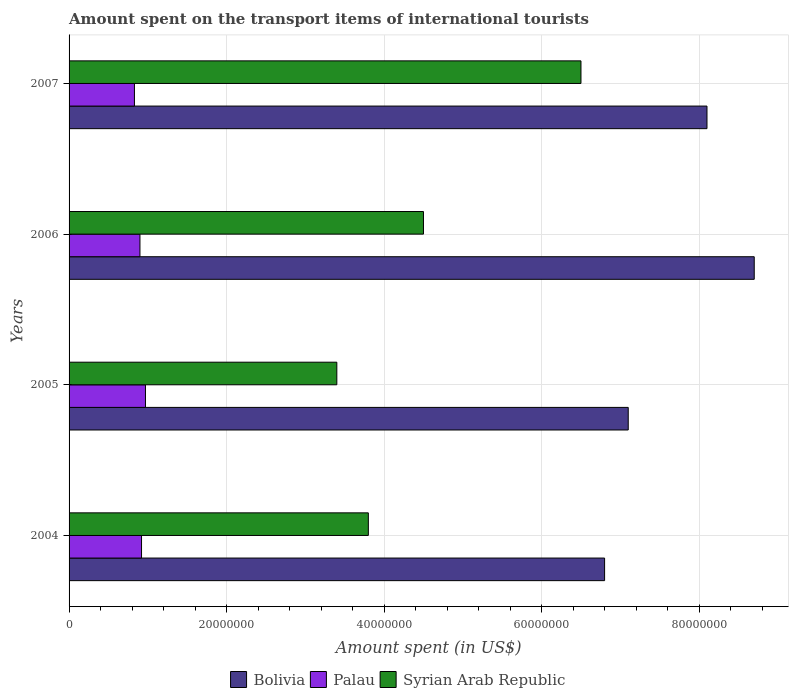Are the number of bars per tick equal to the number of legend labels?
Make the answer very short. Yes. How many bars are there on the 1st tick from the bottom?
Your answer should be very brief. 3. What is the amount spent on the transport items of international tourists in Palau in 2006?
Offer a very short reply. 9.00e+06. Across all years, what is the maximum amount spent on the transport items of international tourists in Bolivia?
Your response must be concise. 8.70e+07. Across all years, what is the minimum amount spent on the transport items of international tourists in Syrian Arab Republic?
Your answer should be compact. 3.40e+07. What is the total amount spent on the transport items of international tourists in Palau in the graph?
Offer a very short reply. 3.62e+07. What is the difference between the amount spent on the transport items of international tourists in Palau in 2006 and the amount spent on the transport items of international tourists in Syrian Arab Republic in 2007?
Provide a succinct answer. -5.60e+07. What is the average amount spent on the transport items of international tourists in Palau per year?
Your response must be concise. 9.05e+06. In the year 2007, what is the difference between the amount spent on the transport items of international tourists in Bolivia and amount spent on the transport items of international tourists in Syrian Arab Republic?
Provide a short and direct response. 1.60e+07. In how many years, is the amount spent on the transport items of international tourists in Bolivia greater than 32000000 US$?
Give a very brief answer. 4. What is the ratio of the amount spent on the transport items of international tourists in Bolivia in 2004 to that in 2007?
Provide a short and direct response. 0.84. Is the difference between the amount spent on the transport items of international tourists in Bolivia in 2006 and 2007 greater than the difference between the amount spent on the transport items of international tourists in Syrian Arab Republic in 2006 and 2007?
Provide a succinct answer. Yes. What is the difference between the highest and the second highest amount spent on the transport items of international tourists in Palau?
Your answer should be very brief. 5.00e+05. What is the difference between the highest and the lowest amount spent on the transport items of international tourists in Bolivia?
Offer a very short reply. 1.90e+07. In how many years, is the amount spent on the transport items of international tourists in Palau greater than the average amount spent on the transport items of international tourists in Palau taken over all years?
Keep it short and to the point. 2. Is the sum of the amount spent on the transport items of international tourists in Palau in 2006 and 2007 greater than the maximum amount spent on the transport items of international tourists in Syrian Arab Republic across all years?
Your answer should be very brief. No. What does the 1st bar from the top in 2006 represents?
Give a very brief answer. Syrian Arab Republic. How many bars are there?
Your response must be concise. 12. Are all the bars in the graph horizontal?
Keep it short and to the point. Yes. What is the difference between two consecutive major ticks on the X-axis?
Provide a succinct answer. 2.00e+07. Does the graph contain grids?
Offer a terse response. Yes. Where does the legend appear in the graph?
Your response must be concise. Bottom center. How many legend labels are there?
Keep it short and to the point. 3. How are the legend labels stacked?
Offer a very short reply. Horizontal. What is the title of the graph?
Your answer should be compact. Amount spent on the transport items of international tourists. Does "Algeria" appear as one of the legend labels in the graph?
Keep it short and to the point. No. What is the label or title of the X-axis?
Ensure brevity in your answer.  Amount spent (in US$). What is the label or title of the Y-axis?
Your response must be concise. Years. What is the Amount spent (in US$) of Bolivia in 2004?
Offer a very short reply. 6.80e+07. What is the Amount spent (in US$) in Palau in 2004?
Your answer should be compact. 9.20e+06. What is the Amount spent (in US$) in Syrian Arab Republic in 2004?
Your response must be concise. 3.80e+07. What is the Amount spent (in US$) in Bolivia in 2005?
Make the answer very short. 7.10e+07. What is the Amount spent (in US$) of Palau in 2005?
Provide a short and direct response. 9.70e+06. What is the Amount spent (in US$) in Syrian Arab Republic in 2005?
Your response must be concise. 3.40e+07. What is the Amount spent (in US$) of Bolivia in 2006?
Offer a very short reply. 8.70e+07. What is the Amount spent (in US$) of Palau in 2006?
Ensure brevity in your answer.  9.00e+06. What is the Amount spent (in US$) in Syrian Arab Republic in 2006?
Make the answer very short. 4.50e+07. What is the Amount spent (in US$) of Bolivia in 2007?
Give a very brief answer. 8.10e+07. What is the Amount spent (in US$) in Palau in 2007?
Offer a very short reply. 8.30e+06. What is the Amount spent (in US$) of Syrian Arab Republic in 2007?
Your answer should be very brief. 6.50e+07. Across all years, what is the maximum Amount spent (in US$) in Bolivia?
Offer a very short reply. 8.70e+07. Across all years, what is the maximum Amount spent (in US$) of Palau?
Offer a terse response. 9.70e+06. Across all years, what is the maximum Amount spent (in US$) of Syrian Arab Republic?
Provide a short and direct response. 6.50e+07. Across all years, what is the minimum Amount spent (in US$) in Bolivia?
Provide a short and direct response. 6.80e+07. Across all years, what is the minimum Amount spent (in US$) in Palau?
Offer a terse response. 8.30e+06. Across all years, what is the minimum Amount spent (in US$) in Syrian Arab Republic?
Your answer should be compact. 3.40e+07. What is the total Amount spent (in US$) in Bolivia in the graph?
Give a very brief answer. 3.07e+08. What is the total Amount spent (in US$) in Palau in the graph?
Make the answer very short. 3.62e+07. What is the total Amount spent (in US$) in Syrian Arab Republic in the graph?
Your answer should be very brief. 1.82e+08. What is the difference between the Amount spent (in US$) of Palau in 2004 and that in 2005?
Provide a short and direct response. -5.00e+05. What is the difference between the Amount spent (in US$) in Syrian Arab Republic in 2004 and that in 2005?
Make the answer very short. 4.00e+06. What is the difference between the Amount spent (in US$) in Bolivia in 2004 and that in 2006?
Offer a very short reply. -1.90e+07. What is the difference between the Amount spent (in US$) of Palau in 2004 and that in 2006?
Your answer should be very brief. 2.00e+05. What is the difference between the Amount spent (in US$) in Syrian Arab Republic in 2004 and that in 2006?
Give a very brief answer. -7.00e+06. What is the difference between the Amount spent (in US$) in Bolivia in 2004 and that in 2007?
Keep it short and to the point. -1.30e+07. What is the difference between the Amount spent (in US$) of Syrian Arab Republic in 2004 and that in 2007?
Your answer should be very brief. -2.70e+07. What is the difference between the Amount spent (in US$) of Bolivia in 2005 and that in 2006?
Provide a short and direct response. -1.60e+07. What is the difference between the Amount spent (in US$) of Palau in 2005 and that in 2006?
Keep it short and to the point. 7.00e+05. What is the difference between the Amount spent (in US$) in Syrian Arab Republic in 2005 and that in 2006?
Ensure brevity in your answer.  -1.10e+07. What is the difference between the Amount spent (in US$) in Bolivia in 2005 and that in 2007?
Your response must be concise. -1.00e+07. What is the difference between the Amount spent (in US$) of Palau in 2005 and that in 2007?
Make the answer very short. 1.40e+06. What is the difference between the Amount spent (in US$) of Syrian Arab Republic in 2005 and that in 2007?
Offer a terse response. -3.10e+07. What is the difference between the Amount spent (in US$) of Palau in 2006 and that in 2007?
Offer a very short reply. 7.00e+05. What is the difference between the Amount spent (in US$) of Syrian Arab Republic in 2006 and that in 2007?
Offer a terse response. -2.00e+07. What is the difference between the Amount spent (in US$) in Bolivia in 2004 and the Amount spent (in US$) in Palau in 2005?
Your response must be concise. 5.83e+07. What is the difference between the Amount spent (in US$) of Bolivia in 2004 and the Amount spent (in US$) of Syrian Arab Republic in 2005?
Your response must be concise. 3.40e+07. What is the difference between the Amount spent (in US$) in Palau in 2004 and the Amount spent (in US$) in Syrian Arab Republic in 2005?
Ensure brevity in your answer.  -2.48e+07. What is the difference between the Amount spent (in US$) of Bolivia in 2004 and the Amount spent (in US$) of Palau in 2006?
Keep it short and to the point. 5.90e+07. What is the difference between the Amount spent (in US$) in Bolivia in 2004 and the Amount spent (in US$) in Syrian Arab Republic in 2006?
Ensure brevity in your answer.  2.30e+07. What is the difference between the Amount spent (in US$) in Palau in 2004 and the Amount spent (in US$) in Syrian Arab Republic in 2006?
Your answer should be compact. -3.58e+07. What is the difference between the Amount spent (in US$) in Bolivia in 2004 and the Amount spent (in US$) in Palau in 2007?
Your response must be concise. 5.97e+07. What is the difference between the Amount spent (in US$) of Bolivia in 2004 and the Amount spent (in US$) of Syrian Arab Republic in 2007?
Make the answer very short. 3.00e+06. What is the difference between the Amount spent (in US$) of Palau in 2004 and the Amount spent (in US$) of Syrian Arab Republic in 2007?
Give a very brief answer. -5.58e+07. What is the difference between the Amount spent (in US$) in Bolivia in 2005 and the Amount spent (in US$) in Palau in 2006?
Your answer should be compact. 6.20e+07. What is the difference between the Amount spent (in US$) in Bolivia in 2005 and the Amount spent (in US$) in Syrian Arab Republic in 2006?
Your response must be concise. 2.60e+07. What is the difference between the Amount spent (in US$) of Palau in 2005 and the Amount spent (in US$) of Syrian Arab Republic in 2006?
Offer a very short reply. -3.53e+07. What is the difference between the Amount spent (in US$) of Bolivia in 2005 and the Amount spent (in US$) of Palau in 2007?
Provide a succinct answer. 6.27e+07. What is the difference between the Amount spent (in US$) in Palau in 2005 and the Amount spent (in US$) in Syrian Arab Republic in 2007?
Ensure brevity in your answer.  -5.53e+07. What is the difference between the Amount spent (in US$) in Bolivia in 2006 and the Amount spent (in US$) in Palau in 2007?
Offer a very short reply. 7.87e+07. What is the difference between the Amount spent (in US$) of Bolivia in 2006 and the Amount spent (in US$) of Syrian Arab Republic in 2007?
Provide a succinct answer. 2.20e+07. What is the difference between the Amount spent (in US$) in Palau in 2006 and the Amount spent (in US$) in Syrian Arab Republic in 2007?
Your answer should be very brief. -5.60e+07. What is the average Amount spent (in US$) of Bolivia per year?
Offer a terse response. 7.68e+07. What is the average Amount spent (in US$) of Palau per year?
Provide a succinct answer. 9.05e+06. What is the average Amount spent (in US$) in Syrian Arab Republic per year?
Keep it short and to the point. 4.55e+07. In the year 2004, what is the difference between the Amount spent (in US$) in Bolivia and Amount spent (in US$) in Palau?
Provide a succinct answer. 5.88e+07. In the year 2004, what is the difference between the Amount spent (in US$) in Bolivia and Amount spent (in US$) in Syrian Arab Republic?
Your response must be concise. 3.00e+07. In the year 2004, what is the difference between the Amount spent (in US$) in Palau and Amount spent (in US$) in Syrian Arab Republic?
Offer a very short reply. -2.88e+07. In the year 2005, what is the difference between the Amount spent (in US$) in Bolivia and Amount spent (in US$) in Palau?
Keep it short and to the point. 6.13e+07. In the year 2005, what is the difference between the Amount spent (in US$) of Bolivia and Amount spent (in US$) of Syrian Arab Republic?
Make the answer very short. 3.70e+07. In the year 2005, what is the difference between the Amount spent (in US$) of Palau and Amount spent (in US$) of Syrian Arab Republic?
Your answer should be very brief. -2.43e+07. In the year 2006, what is the difference between the Amount spent (in US$) in Bolivia and Amount spent (in US$) in Palau?
Keep it short and to the point. 7.80e+07. In the year 2006, what is the difference between the Amount spent (in US$) in Bolivia and Amount spent (in US$) in Syrian Arab Republic?
Your answer should be very brief. 4.20e+07. In the year 2006, what is the difference between the Amount spent (in US$) in Palau and Amount spent (in US$) in Syrian Arab Republic?
Provide a succinct answer. -3.60e+07. In the year 2007, what is the difference between the Amount spent (in US$) in Bolivia and Amount spent (in US$) in Palau?
Offer a terse response. 7.27e+07. In the year 2007, what is the difference between the Amount spent (in US$) of Bolivia and Amount spent (in US$) of Syrian Arab Republic?
Make the answer very short. 1.60e+07. In the year 2007, what is the difference between the Amount spent (in US$) of Palau and Amount spent (in US$) of Syrian Arab Republic?
Offer a terse response. -5.67e+07. What is the ratio of the Amount spent (in US$) of Bolivia in 2004 to that in 2005?
Your answer should be compact. 0.96. What is the ratio of the Amount spent (in US$) of Palau in 2004 to that in 2005?
Your response must be concise. 0.95. What is the ratio of the Amount spent (in US$) of Syrian Arab Republic in 2004 to that in 2005?
Offer a terse response. 1.12. What is the ratio of the Amount spent (in US$) of Bolivia in 2004 to that in 2006?
Make the answer very short. 0.78. What is the ratio of the Amount spent (in US$) of Palau in 2004 to that in 2006?
Make the answer very short. 1.02. What is the ratio of the Amount spent (in US$) of Syrian Arab Republic in 2004 to that in 2006?
Give a very brief answer. 0.84. What is the ratio of the Amount spent (in US$) of Bolivia in 2004 to that in 2007?
Offer a very short reply. 0.84. What is the ratio of the Amount spent (in US$) in Palau in 2004 to that in 2007?
Give a very brief answer. 1.11. What is the ratio of the Amount spent (in US$) of Syrian Arab Republic in 2004 to that in 2007?
Your answer should be compact. 0.58. What is the ratio of the Amount spent (in US$) in Bolivia in 2005 to that in 2006?
Provide a short and direct response. 0.82. What is the ratio of the Amount spent (in US$) in Palau in 2005 to that in 2006?
Offer a terse response. 1.08. What is the ratio of the Amount spent (in US$) of Syrian Arab Republic in 2005 to that in 2006?
Your answer should be very brief. 0.76. What is the ratio of the Amount spent (in US$) in Bolivia in 2005 to that in 2007?
Offer a terse response. 0.88. What is the ratio of the Amount spent (in US$) in Palau in 2005 to that in 2007?
Offer a terse response. 1.17. What is the ratio of the Amount spent (in US$) in Syrian Arab Republic in 2005 to that in 2007?
Your response must be concise. 0.52. What is the ratio of the Amount spent (in US$) in Bolivia in 2006 to that in 2007?
Offer a very short reply. 1.07. What is the ratio of the Amount spent (in US$) in Palau in 2006 to that in 2007?
Ensure brevity in your answer.  1.08. What is the ratio of the Amount spent (in US$) of Syrian Arab Republic in 2006 to that in 2007?
Provide a succinct answer. 0.69. What is the difference between the highest and the second highest Amount spent (in US$) in Palau?
Your answer should be compact. 5.00e+05. What is the difference between the highest and the lowest Amount spent (in US$) in Bolivia?
Keep it short and to the point. 1.90e+07. What is the difference between the highest and the lowest Amount spent (in US$) in Palau?
Provide a short and direct response. 1.40e+06. What is the difference between the highest and the lowest Amount spent (in US$) in Syrian Arab Republic?
Offer a very short reply. 3.10e+07. 